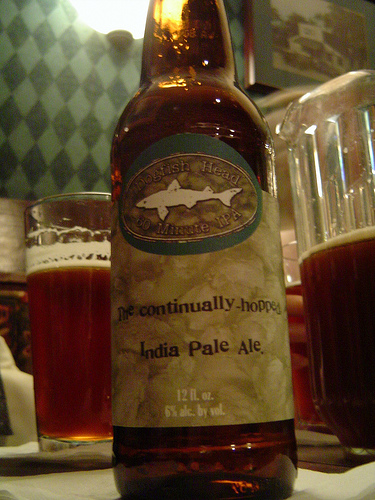<image>
Is there a bottle under the glass? No. The bottle is not positioned under the glass. The vertical relationship between these objects is different. Is there a beer behind the bottle? Yes. From this viewpoint, the beer is positioned behind the bottle, with the bottle partially or fully occluding the beer. 